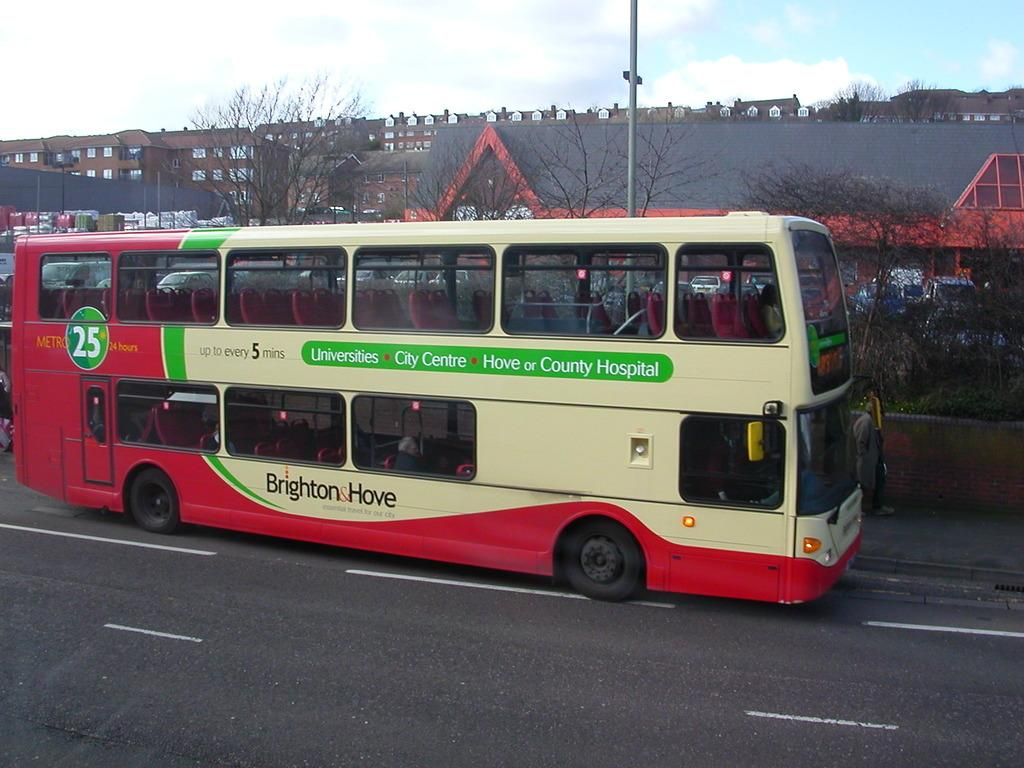<image>
Relay a brief, clear account of the picture shown. A white, green and red bus with Brighton and Hove written on it. 